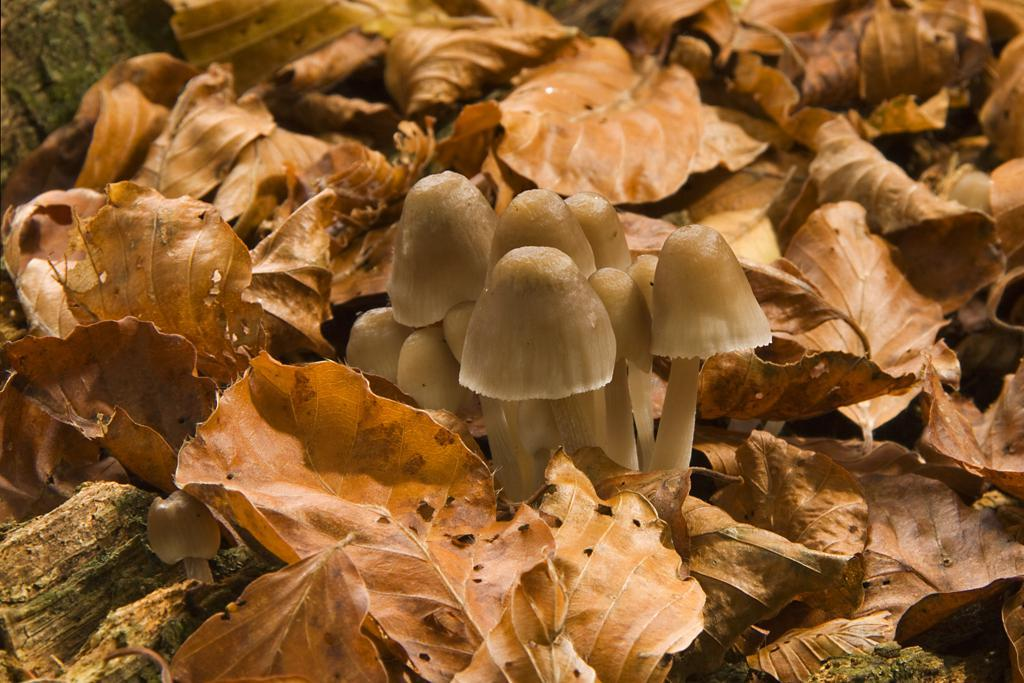What type of fungi can be seen in the image? There are mushrooms in the image. What color are the mushrooms? The mushrooms are in cream color. What other natural elements are present in the image? There are dried leaves in the image. What color are the dried leaves? The dried leaves are in brown color. What type of oatmeal is being prepared in the image? There is no oatmeal or any indication of food preparation in the image. 